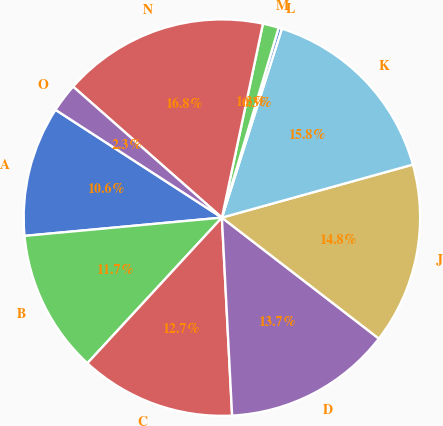Convert chart to OTSL. <chart><loc_0><loc_0><loc_500><loc_500><pie_chart><fcel>A<fcel>B<fcel>C<fcel>D<fcel>J<fcel>K<fcel>L<fcel>M<fcel>N<fcel>O<nl><fcel>10.62%<fcel>11.66%<fcel>12.69%<fcel>13.73%<fcel>14.76%<fcel>15.8%<fcel>0.27%<fcel>1.3%<fcel>16.83%<fcel>2.34%<nl></chart> 